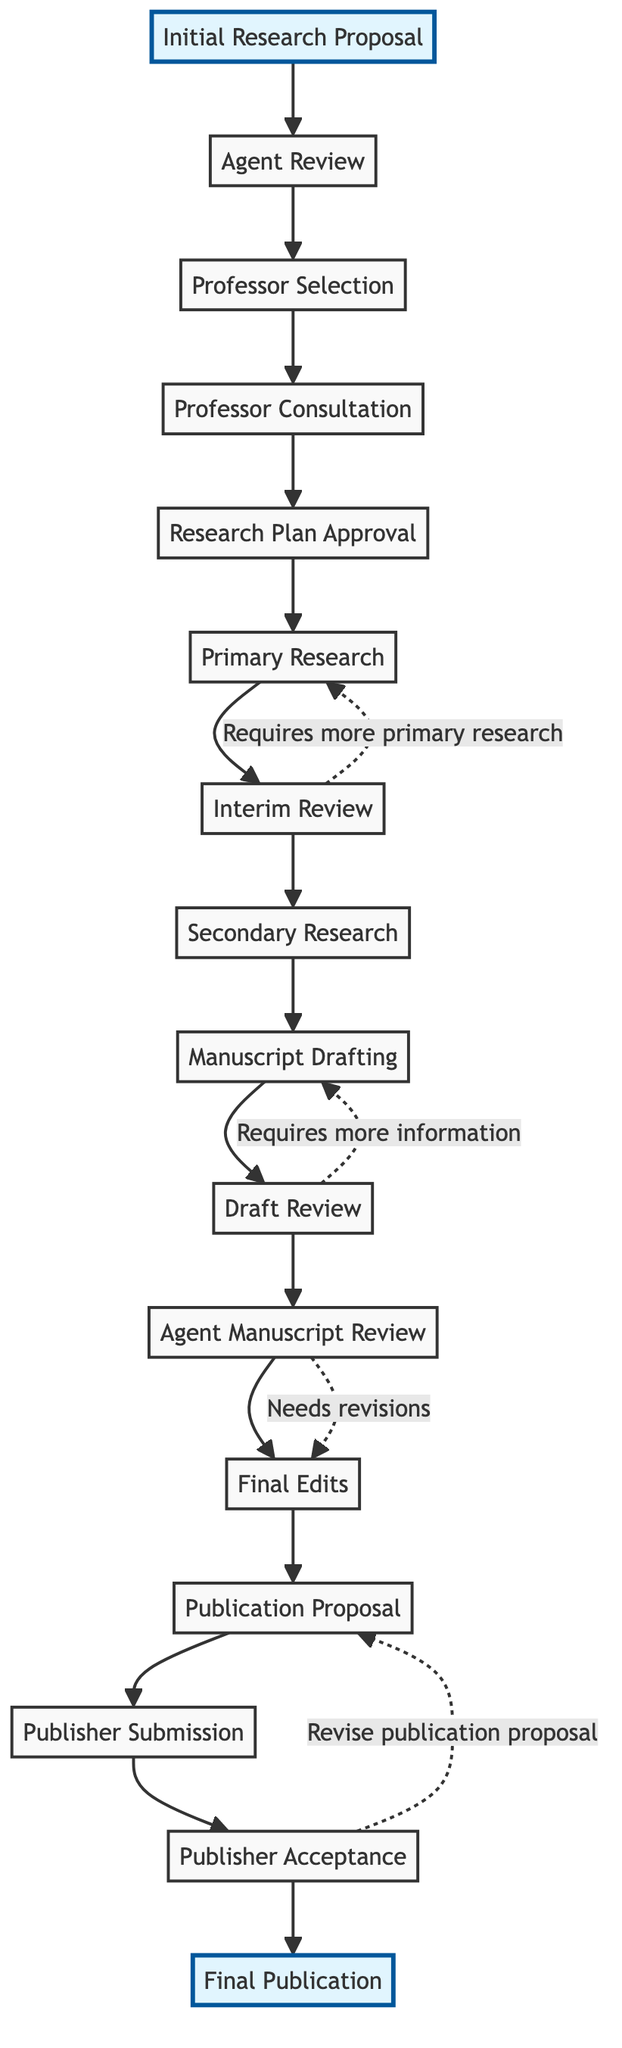What is the first step in the collaboration process? The diagram starts with the node labeled "Initial Research Proposal," indicating it is the first step taken by the author.
Answer: Initial Research Proposal How many nodes are in the diagram? The diagram contains a total of 16 nodes, which include all steps from the initial research proposal to the final publication.
Answer: 16 What action occurs after the "Agent Review"? After the "Agent Review," the next action is "Professor Selection," which follows in the sequence of the collaboration process.
Answer: Professor Selection Which step involves the author presenting findings? The author presents interim findings in the "Interim Review," where feedback is provided by the professor and agent.
Answer: Interim Review What step comes before "Final Publication"? The step that comes before "Final Publication" is "Publisher Acceptance," as indicated by the direction of the arrows connecting the nodes.
Answer: Publisher Acceptance What feedback loop occurs after "Interim Review"? The feedback loop from "Interim Review" indicates that if more primary research is required, the author returns to "Primary Research" for additional work.
Answer: Requires more primary research Which document is prepared for submission to publishers? "Publication Proposal" is the document that the agent prepares for submission to publishers, following the final edits made by the author.
Answer: Publication Proposal Which two steps require revisions? "Draft Review" and "Agent Manuscript Review" both lead to "Final Edits," which indicates they involve feedback that necessitates revisions.
Answer: Draft Review, Agent Manuscript Review What is the final step in the process? The final step in the collaboration process is "Final Publication," which represents the completion and distribution of the book.
Answer: Final Publication 